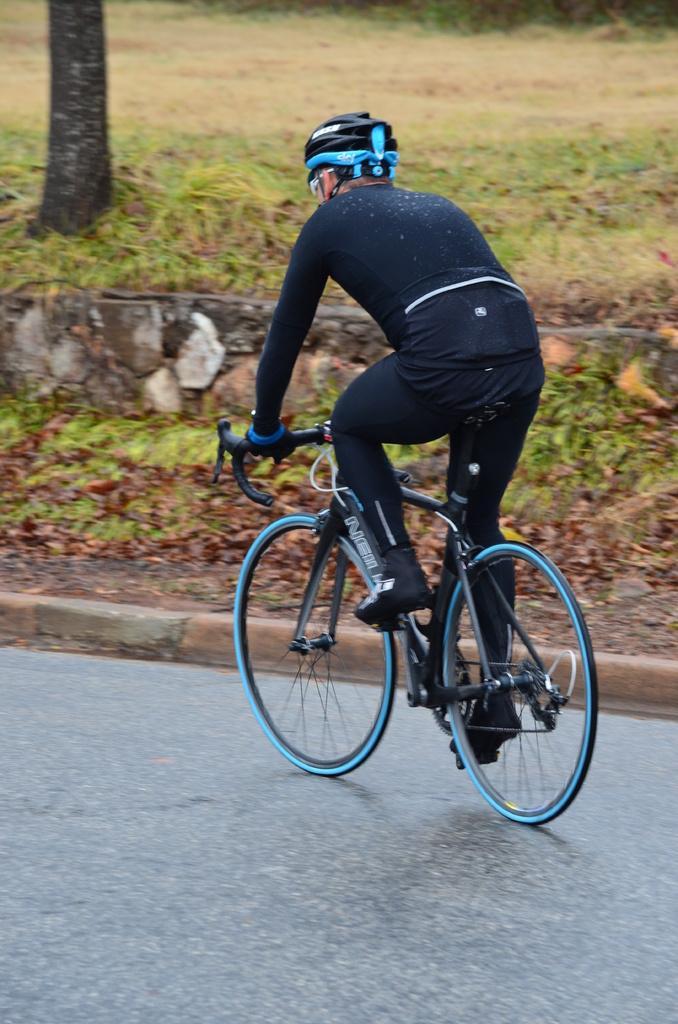In one or two sentences, can you explain what this image depicts? In this picture we can see a person is riding a bicycle on the road. In front of the person, there is a tree trunk, grass and it looks like a wall. 